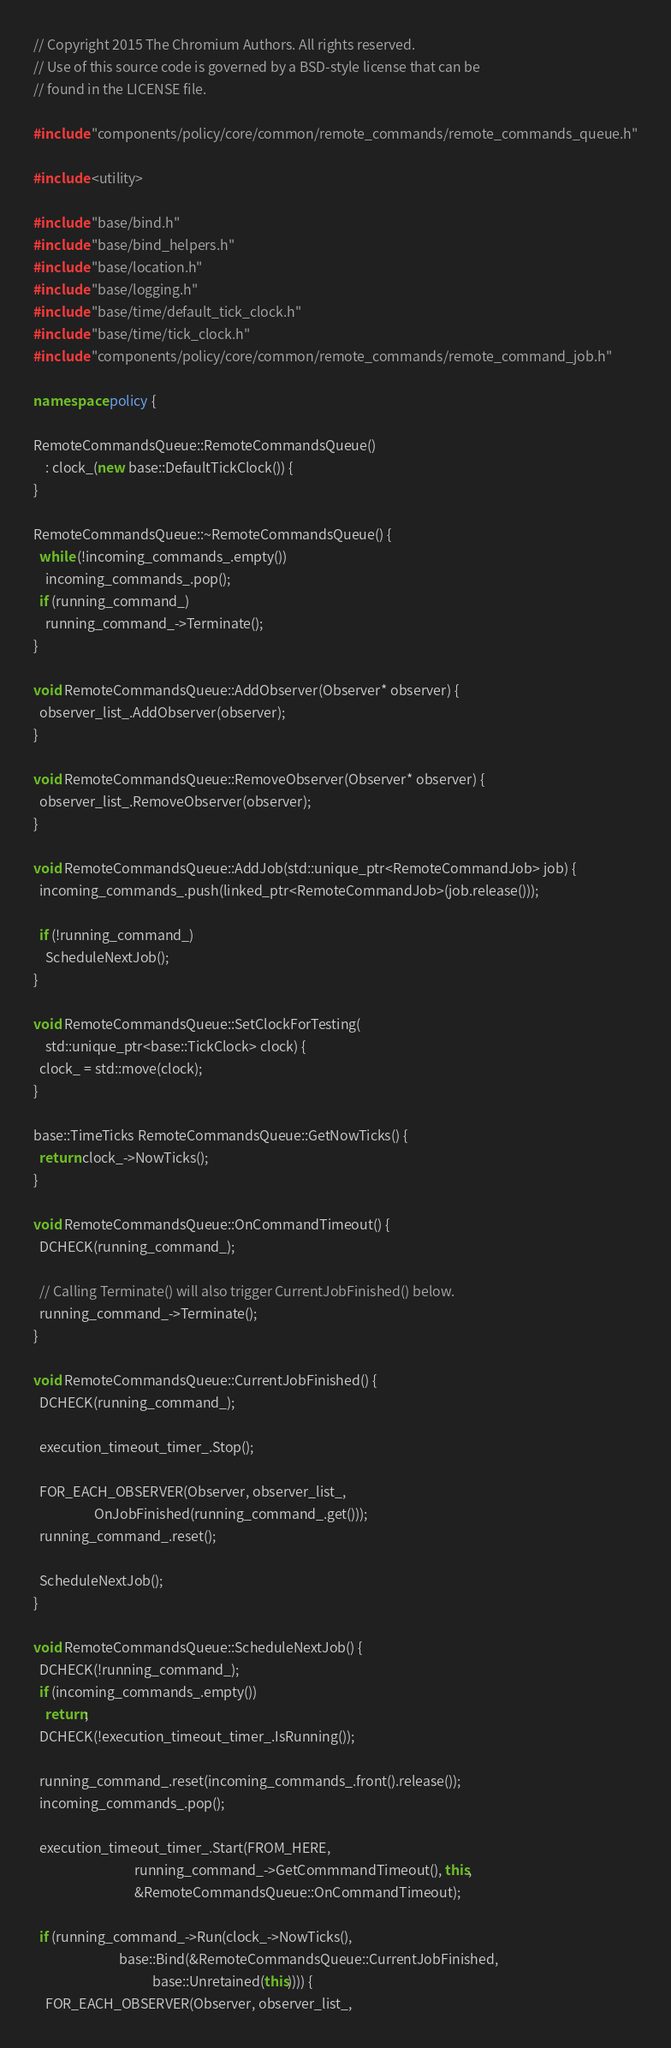<code> <loc_0><loc_0><loc_500><loc_500><_C++_>// Copyright 2015 The Chromium Authors. All rights reserved.
// Use of this source code is governed by a BSD-style license that can be
// found in the LICENSE file.

#include "components/policy/core/common/remote_commands/remote_commands_queue.h"

#include <utility>

#include "base/bind.h"
#include "base/bind_helpers.h"
#include "base/location.h"
#include "base/logging.h"
#include "base/time/default_tick_clock.h"
#include "base/time/tick_clock.h"
#include "components/policy/core/common/remote_commands/remote_command_job.h"

namespace policy {

RemoteCommandsQueue::RemoteCommandsQueue()
    : clock_(new base::DefaultTickClock()) {
}

RemoteCommandsQueue::~RemoteCommandsQueue() {
  while (!incoming_commands_.empty())
    incoming_commands_.pop();
  if (running_command_)
    running_command_->Terminate();
}

void RemoteCommandsQueue::AddObserver(Observer* observer) {
  observer_list_.AddObserver(observer);
}

void RemoteCommandsQueue::RemoveObserver(Observer* observer) {
  observer_list_.RemoveObserver(observer);
}

void RemoteCommandsQueue::AddJob(std::unique_ptr<RemoteCommandJob> job) {
  incoming_commands_.push(linked_ptr<RemoteCommandJob>(job.release()));

  if (!running_command_)
    ScheduleNextJob();
}

void RemoteCommandsQueue::SetClockForTesting(
    std::unique_ptr<base::TickClock> clock) {
  clock_ = std::move(clock);
}

base::TimeTicks RemoteCommandsQueue::GetNowTicks() {
  return clock_->NowTicks();
}

void RemoteCommandsQueue::OnCommandTimeout() {
  DCHECK(running_command_);

  // Calling Terminate() will also trigger CurrentJobFinished() below.
  running_command_->Terminate();
}

void RemoteCommandsQueue::CurrentJobFinished() {
  DCHECK(running_command_);

  execution_timeout_timer_.Stop();

  FOR_EACH_OBSERVER(Observer, observer_list_,
                    OnJobFinished(running_command_.get()));
  running_command_.reset();

  ScheduleNextJob();
}

void RemoteCommandsQueue::ScheduleNextJob() {
  DCHECK(!running_command_);
  if (incoming_commands_.empty())
    return;
  DCHECK(!execution_timeout_timer_.IsRunning());

  running_command_.reset(incoming_commands_.front().release());
  incoming_commands_.pop();

  execution_timeout_timer_.Start(FROM_HERE,
                                 running_command_->GetCommmandTimeout(), this,
                                 &RemoteCommandsQueue::OnCommandTimeout);

  if (running_command_->Run(clock_->NowTicks(),
                            base::Bind(&RemoteCommandsQueue::CurrentJobFinished,
                                       base::Unretained(this)))) {
    FOR_EACH_OBSERVER(Observer, observer_list_,</code> 